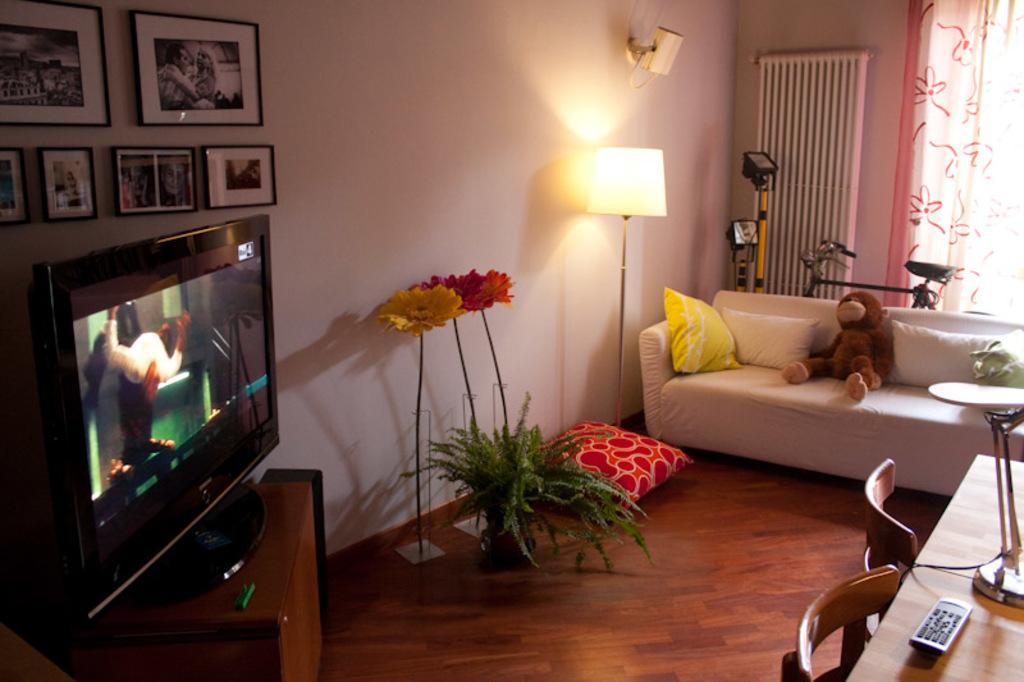How would you summarize this image in a sentence or two? In this image we can see television,couch,pillow,lamp,table chair. The frames are attached to the wall. 